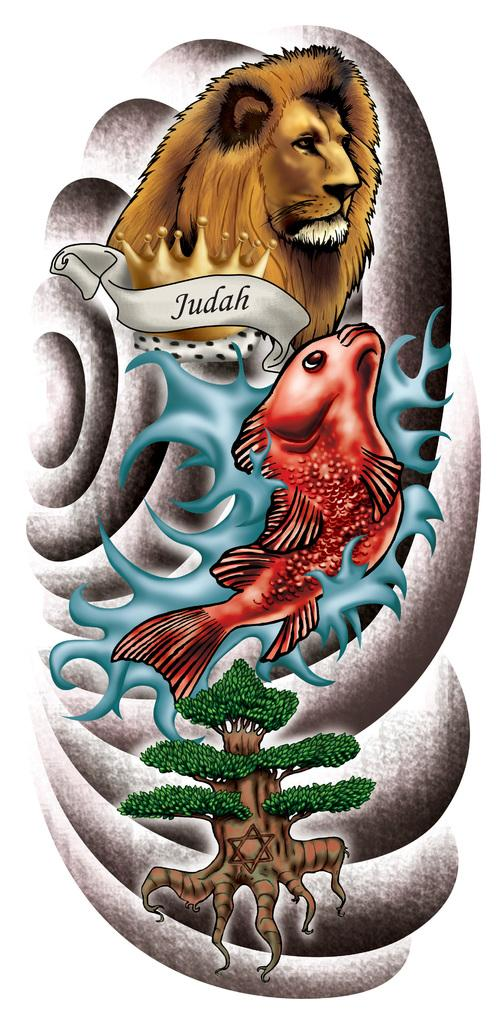What type of editing has been done to the image? The image is edited, but the specific type of editing is not mentioned in the facts. What animals are present in the image? There are fish and a lion in the image. What type of plant is in the image? There is a tree in the image. What color is the background of the image? The background of the image is white. What type of umbrella is being used by the lion in the image? There is no umbrella present in the image, and the lion is not using any unit to measure the arithmetic in the image? 